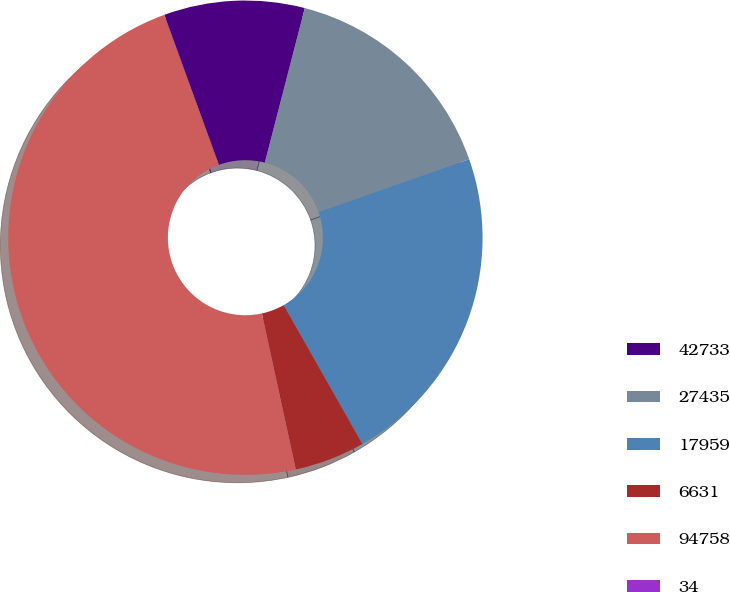Convert chart. <chart><loc_0><loc_0><loc_500><loc_500><pie_chart><fcel>42733<fcel>27435<fcel>17959<fcel>6631<fcel>94758<fcel>34<nl><fcel>9.58%<fcel>15.6%<fcel>22.16%<fcel>4.8%<fcel>47.84%<fcel>0.02%<nl></chart> 